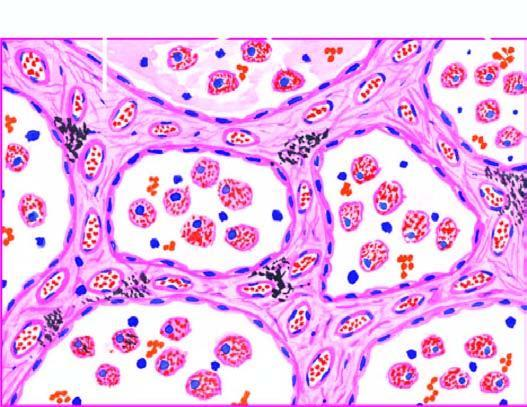why are the alveolar septa widened?
Answer the question using a single word or phrase. Due to congestion 